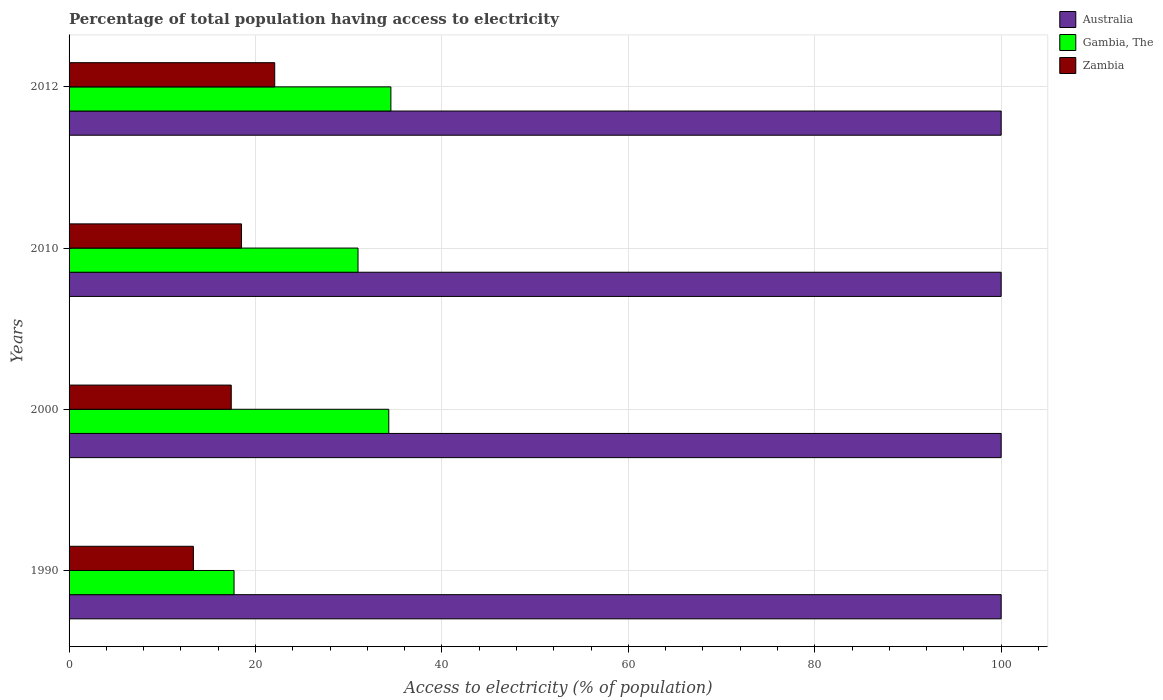Are the number of bars per tick equal to the number of legend labels?
Your response must be concise. Yes. Are the number of bars on each tick of the Y-axis equal?
Give a very brief answer. Yes. How many bars are there on the 2nd tick from the top?
Your answer should be very brief. 3. What is the label of the 1st group of bars from the top?
Your response must be concise. 2012. In how many cases, is the number of bars for a given year not equal to the number of legend labels?
Offer a terse response. 0. What is the percentage of population that have access to electricity in Australia in 2012?
Give a very brief answer. 100. Across all years, what is the maximum percentage of population that have access to electricity in Australia?
Provide a succinct answer. 100. Across all years, what is the minimum percentage of population that have access to electricity in Gambia, The?
Offer a very short reply. 17.7. In which year was the percentage of population that have access to electricity in Zambia minimum?
Provide a short and direct response. 1990. What is the total percentage of population that have access to electricity in Zambia in the graph?
Your answer should be very brief. 71.3. What is the difference between the percentage of population that have access to electricity in Zambia in 2010 and that in 2012?
Your answer should be compact. -3.56. What is the difference between the percentage of population that have access to electricity in Gambia, The in 1990 and the percentage of population that have access to electricity in Zambia in 2010?
Make the answer very short. -0.8. What is the average percentage of population that have access to electricity in Gambia, The per year?
Provide a succinct answer. 29.38. In the year 2012, what is the difference between the percentage of population that have access to electricity in Australia and percentage of population that have access to electricity in Zambia?
Offer a terse response. 77.94. In how many years, is the percentage of population that have access to electricity in Australia greater than 68 %?
Your response must be concise. 4. What is the difference between the highest and the lowest percentage of population that have access to electricity in Zambia?
Your answer should be very brief. 8.72. What does the 1st bar from the top in 1990 represents?
Your response must be concise. Zambia. What does the 3rd bar from the bottom in 2010 represents?
Keep it short and to the point. Zambia. How many bars are there?
Provide a succinct answer. 12. Are the values on the major ticks of X-axis written in scientific E-notation?
Keep it short and to the point. No. Does the graph contain grids?
Offer a very short reply. Yes. How are the legend labels stacked?
Provide a short and direct response. Vertical. What is the title of the graph?
Make the answer very short. Percentage of total population having access to electricity. Does "Poland" appear as one of the legend labels in the graph?
Provide a succinct answer. No. What is the label or title of the X-axis?
Make the answer very short. Access to electricity (% of population). What is the Access to electricity (% of population) in Australia in 1990?
Provide a short and direct response. 100. What is the Access to electricity (% of population) of Gambia, The in 1990?
Offer a very short reply. 17.7. What is the Access to electricity (% of population) in Zambia in 1990?
Offer a very short reply. 13.34. What is the Access to electricity (% of population) in Gambia, The in 2000?
Provide a short and direct response. 34.3. What is the Access to electricity (% of population) of Australia in 2010?
Offer a very short reply. 100. What is the Access to electricity (% of population) of Australia in 2012?
Offer a very short reply. 100. What is the Access to electricity (% of population) of Gambia, The in 2012?
Ensure brevity in your answer.  34.53. What is the Access to electricity (% of population) of Zambia in 2012?
Provide a succinct answer. 22.06. Across all years, what is the maximum Access to electricity (% of population) in Australia?
Provide a succinct answer. 100. Across all years, what is the maximum Access to electricity (% of population) in Gambia, The?
Your response must be concise. 34.53. Across all years, what is the maximum Access to electricity (% of population) of Zambia?
Give a very brief answer. 22.06. Across all years, what is the minimum Access to electricity (% of population) in Zambia?
Give a very brief answer. 13.34. What is the total Access to electricity (% of population) in Australia in the graph?
Provide a succinct answer. 400. What is the total Access to electricity (% of population) in Gambia, The in the graph?
Ensure brevity in your answer.  117.53. What is the total Access to electricity (% of population) of Zambia in the graph?
Ensure brevity in your answer.  71.3. What is the difference between the Access to electricity (% of population) of Gambia, The in 1990 and that in 2000?
Offer a very short reply. -16.6. What is the difference between the Access to electricity (% of population) of Zambia in 1990 and that in 2000?
Ensure brevity in your answer.  -4.06. What is the difference between the Access to electricity (% of population) of Australia in 1990 and that in 2010?
Your answer should be very brief. 0. What is the difference between the Access to electricity (% of population) of Zambia in 1990 and that in 2010?
Ensure brevity in your answer.  -5.16. What is the difference between the Access to electricity (% of population) in Gambia, The in 1990 and that in 2012?
Your answer should be very brief. -16.83. What is the difference between the Access to electricity (% of population) in Zambia in 1990 and that in 2012?
Your answer should be very brief. -8.72. What is the difference between the Access to electricity (% of population) of Australia in 2000 and that in 2010?
Make the answer very short. 0. What is the difference between the Access to electricity (% of population) of Zambia in 2000 and that in 2010?
Offer a terse response. -1.1. What is the difference between the Access to electricity (% of population) in Gambia, The in 2000 and that in 2012?
Your response must be concise. -0.23. What is the difference between the Access to electricity (% of population) in Zambia in 2000 and that in 2012?
Ensure brevity in your answer.  -4.66. What is the difference between the Access to electricity (% of population) in Gambia, The in 2010 and that in 2012?
Your response must be concise. -3.53. What is the difference between the Access to electricity (% of population) in Zambia in 2010 and that in 2012?
Your response must be concise. -3.56. What is the difference between the Access to electricity (% of population) of Australia in 1990 and the Access to electricity (% of population) of Gambia, The in 2000?
Offer a very short reply. 65.7. What is the difference between the Access to electricity (% of population) of Australia in 1990 and the Access to electricity (% of population) of Zambia in 2000?
Your answer should be very brief. 82.6. What is the difference between the Access to electricity (% of population) in Australia in 1990 and the Access to electricity (% of population) in Gambia, The in 2010?
Offer a very short reply. 69. What is the difference between the Access to electricity (% of population) in Australia in 1990 and the Access to electricity (% of population) in Zambia in 2010?
Provide a succinct answer. 81.5. What is the difference between the Access to electricity (% of population) of Australia in 1990 and the Access to electricity (% of population) of Gambia, The in 2012?
Ensure brevity in your answer.  65.47. What is the difference between the Access to electricity (% of population) of Australia in 1990 and the Access to electricity (% of population) of Zambia in 2012?
Your response must be concise. 77.94. What is the difference between the Access to electricity (% of population) in Gambia, The in 1990 and the Access to electricity (% of population) in Zambia in 2012?
Your answer should be very brief. -4.36. What is the difference between the Access to electricity (% of population) of Australia in 2000 and the Access to electricity (% of population) of Gambia, The in 2010?
Keep it short and to the point. 69. What is the difference between the Access to electricity (% of population) of Australia in 2000 and the Access to electricity (% of population) of Zambia in 2010?
Your answer should be very brief. 81.5. What is the difference between the Access to electricity (% of population) in Gambia, The in 2000 and the Access to electricity (% of population) in Zambia in 2010?
Give a very brief answer. 15.8. What is the difference between the Access to electricity (% of population) of Australia in 2000 and the Access to electricity (% of population) of Gambia, The in 2012?
Offer a terse response. 65.47. What is the difference between the Access to electricity (% of population) in Australia in 2000 and the Access to electricity (% of population) in Zambia in 2012?
Give a very brief answer. 77.94. What is the difference between the Access to electricity (% of population) of Gambia, The in 2000 and the Access to electricity (% of population) of Zambia in 2012?
Your answer should be compact. 12.24. What is the difference between the Access to electricity (% of population) of Australia in 2010 and the Access to electricity (% of population) of Gambia, The in 2012?
Ensure brevity in your answer.  65.47. What is the difference between the Access to electricity (% of population) of Australia in 2010 and the Access to electricity (% of population) of Zambia in 2012?
Give a very brief answer. 77.94. What is the difference between the Access to electricity (% of population) of Gambia, The in 2010 and the Access to electricity (% of population) of Zambia in 2012?
Ensure brevity in your answer.  8.94. What is the average Access to electricity (% of population) of Gambia, The per year?
Offer a terse response. 29.38. What is the average Access to electricity (% of population) in Zambia per year?
Your answer should be compact. 17.83. In the year 1990, what is the difference between the Access to electricity (% of population) in Australia and Access to electricity (% of population) in Gambia, The?
Your response must be concise. 82.3. In the year 1990, what is the difference between the Access to electricity (% of population) of Australia and Access to electricity (% of population) of Zambia?
Your answer should be compact. 86.66. In the year 1990, what is the difference between the Access to electricity (% of population) in Gambia, The and Access to electricity (% of population) in Zambia?
Keep it short and to the point. 4.36. In the year 2000, what is the difference between the Access to electricity (% of population) in Australia and Access to electricity (% of population) in Gambia, The?
Give a very brief answer. 65.7. In the year 2000, what is the difference between the Access to electricity (% of population) of Australia and Access to electricity (% of population) of Zambia?
Give a very brief answer. 82.6. In the year 2000, what is the difference between the Access to electricity (% of population) in Gambia, The and Access to electricity (% of population) in Zambia?
Offer a very short reply. 16.9. In the year 2010, what is the difference between the Access to electricity (% of population) in Australia and Access to electricity (% of population) in Zambia?
Your response must be concise. 81.5. In the year 2010, what is the difference between the Access to electricity (% of population) in Gambia, The and Access to electricity (% of population) in Zambia?
Provide a succinct answer. 12.5. In the year 2012, what is the difference between the Access to electricity (% of population) in Australia and Access to electricity (% of population) in Gambia, The?
Ensure brevity in your answer.  65.47. In the year 2012, what is the difference between the Access to electricity (% of population) in Australia and Access to electricity (% of population) in Zambia?
Your answer should be very brief. 77.94. In the year 2012, what is the difference between the Access to electricity (% of population) in Gambia, The and Access to electricity (% of population) in Zambia?
Offer a terse response. 12.46. What is the ratio of the Access to electricity (% of population) in Australia in 1990 to that in 2000?
Provide a short and direct response. 1. What is the ratio of the Access to electricity (% of population) in Gambia, The in 1990 to that in 2000?
Keep it short and to the point. 0.52. What is the ratio of the Access to electricity (% of population) in Zambia in 1990 to that in 2000?
Give a very brief answer. 0.77. What is the ratio of the Access to electricity (% of population) of Australia in 1990 to that in 2010?
Your answer should be compact. 1. What is the ratio of the Access to electricity (% of population) in Gambia, The in 1990 to that in 2010?
Keep it short and to the point. 0.57. What is the ratio of the Access to electricity (% of population) in Zambia in 1990 to that in 2010?
Provide a succinct answer. 0.72. What is the ratio of the Access to electricity (% of population) of Gambia, The in 1990 to that in 2012?
Your answer should be very brief. 0.51. What is the ratio of the Access to electricity (% of population) of Zambia in 1990 to that in 2012?
Offer a terse response. 0.6. What is the ratio of the Access to electricity (% of population) in Australia in 2000 to that in 2010?
Your answer should be very brief. 1. What is the ratio of the Access to electricity (% of population) of Gambia, The in 2000 to that in 2010?
Offer a very short reply. 1.11. What is the ratio of the Access to electricity (% of population) of Zambia in 2000 to that in 2010?
Your response must be concise. 0.94. What is the ratio of the Access to electricity (% of population) in Gambia, The in 2000 to that in 2012?
Offer a terse response. 0.99. What is the ratio of the Access to electricity (% of population) of Zambia in 2000 to that in 2012?
Your answer should be compact. 0.79. What is the ratio of the Access to electricity (% of population) of Gambia, The in 2010 to that in 2012?
Provide a succinct answer. 0.9. What is the ratio of the Access to electricity (% of population) of Zambia in 2010 to that in 2012?
Provide a short and direct response. 0.84. What is the difference between the highest and the second highest Access to electricity (% of population) of Gambia, The?
Your answer should be very brief. 0.23. What is the difference between the highest and the second highest Access to electricity (% of population) of Zambia?
Give a very brief answer. 3.56. What is the difference between the highest and the lowest Access to electricity (% of population) of Australia?
Provide a succinct answer. 0. What is the difference between the highest and the lowest Access to electricity (% of population) of Gambia, The?
Provide a succinct answer. 16.83. What is the difference between the highest and the lowest Access to electricity (% of population) in Zambia?
Keep it short and to the point. 8.72. 